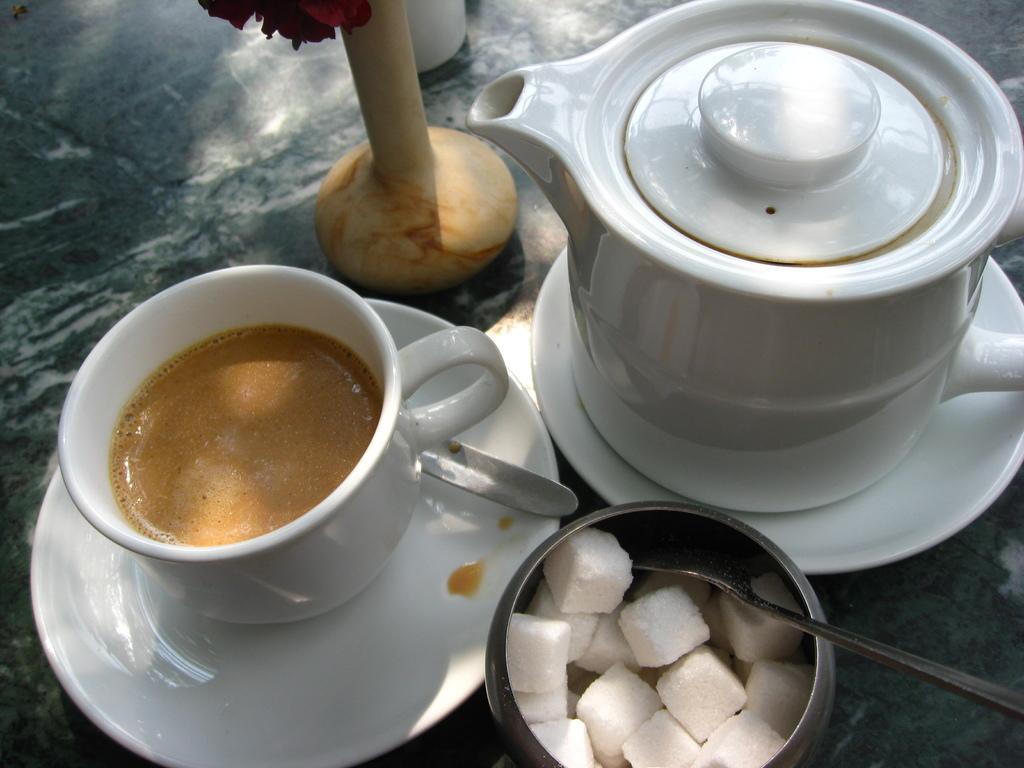Describe this image in one or two sentences. In this image we can see a group of bowls placed on a table with spoons and a flower vase. 